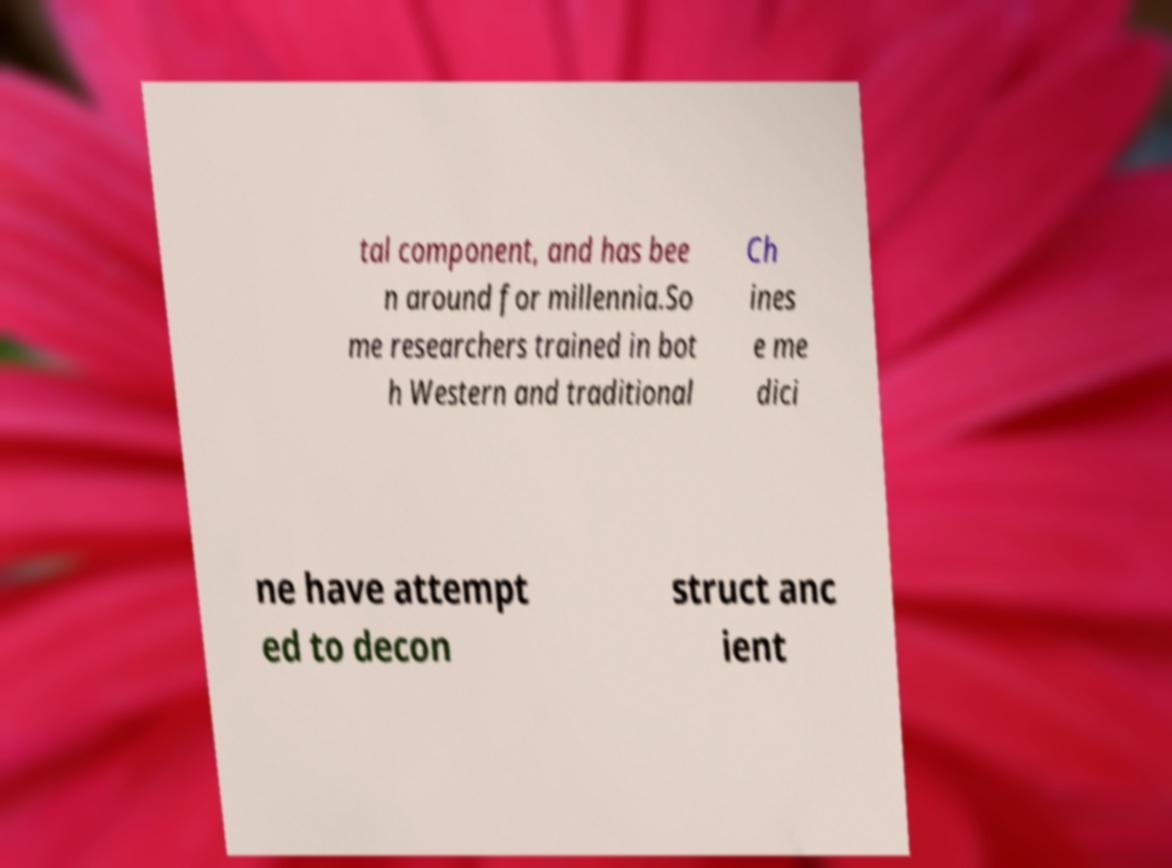I need the written content from this picture converted into text. Can you do that? tal component, and has bee n around for millennia.So me researchers trained in bot h Western and traditional Ch ines e me dici ne have attempt ed to decon struct anc ient 